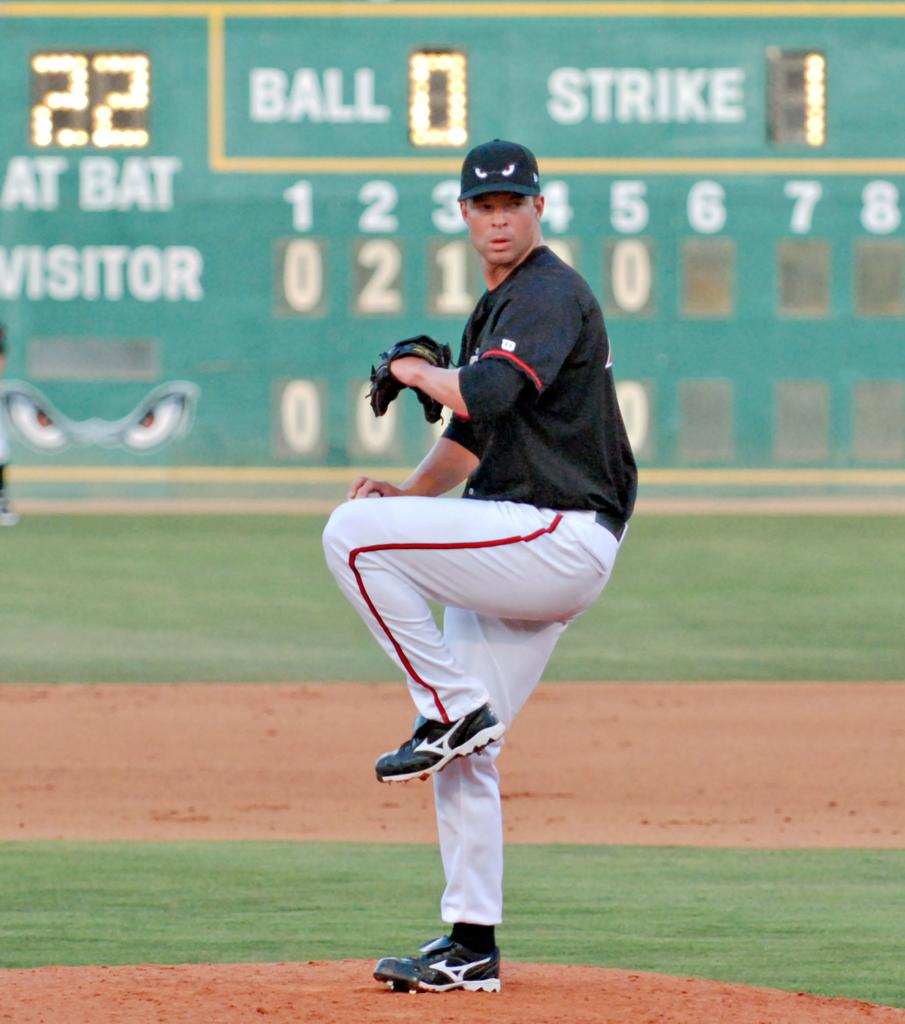Provide a one-sentence caption for the provided image. A pitcher is about to throw the ball in the sixth inning with one strike and no balls for the batter. 